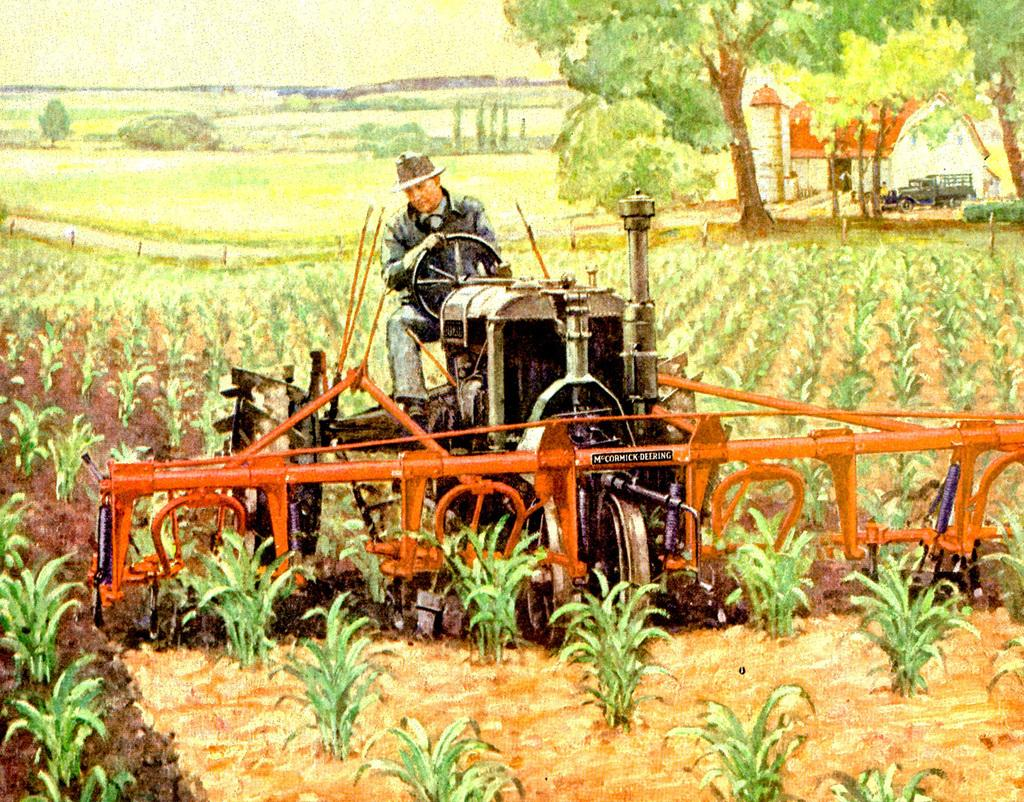What is the main subject of the picture in the image? There is a picture of a person driving a tractor in the image. What can be seen in the background of the image? There are plants visible in the image. What type of vehicle is on the ground in the image? There is a tractor on the ground in the image. What type of structure is present in the image? There is a house in the image. What is visible above the ground in the image? The sky is visible in the image. Where is the swing located in the image? There is no swing present in the image. What type of cracker is being used to water the plants in the image? There is no cracker present in the image, and plants do not require crackers for watering. 